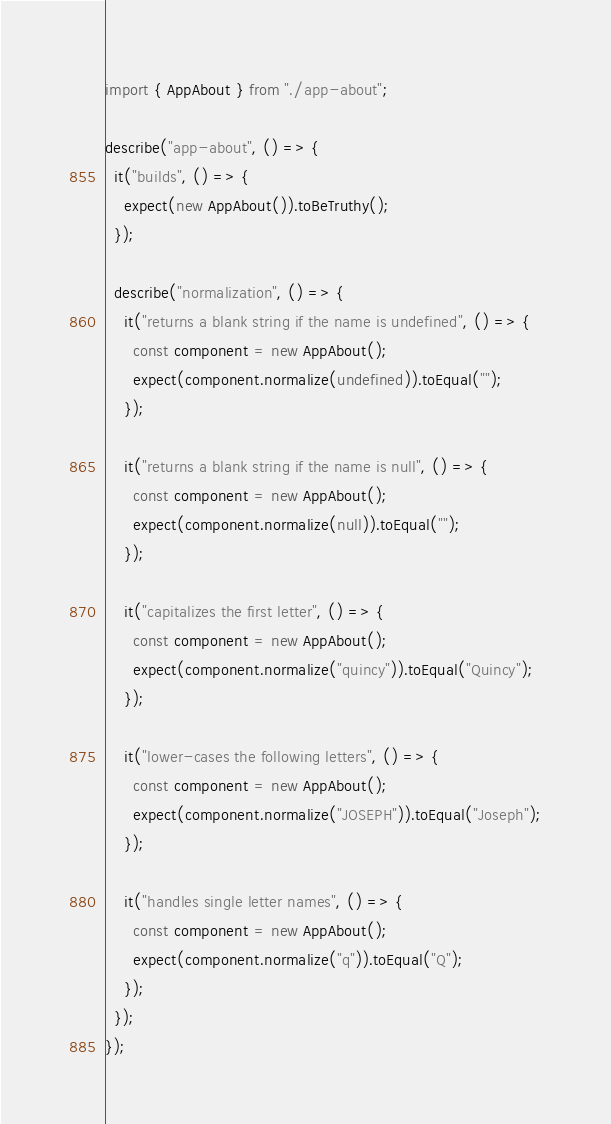<code> <loc_0><loc_0><loc_500><loc_500><_TypeScript_>import { AppAbout } from "./app-about";

describe("app-about", () => {
  it("builds", () => {
    expect(new AppAbout()).toBeTruthy();
  });

  describe("normalization", () => {
    it("returns a blank string if the name is undefined", () => {
      const component = new AppAbout();
      expect(component.normalize(undefined)).toEqual("");
    });

    it("returns a blank string if the name is null", () => {
      const component = new AppAbout();
      expect(component.normalize(null)).toEqual("");
    });

    it("capitalizes the first letter", () => {
      const component = new AppAbout();
      expect(component.normalize("quincy")).toEqual("Quincy");
    });

    it("lower-cases the following letters", () => {
      const component = new AppAbout();
      expect(component.normalize("JOSEPH")).toEqual("Joseph");
    });

    it("handles single letter names", () => {
      const component = new AppAbout();
      expect(component.normalize("q")).toEqual("Q");
    });
  });
});
</code> 